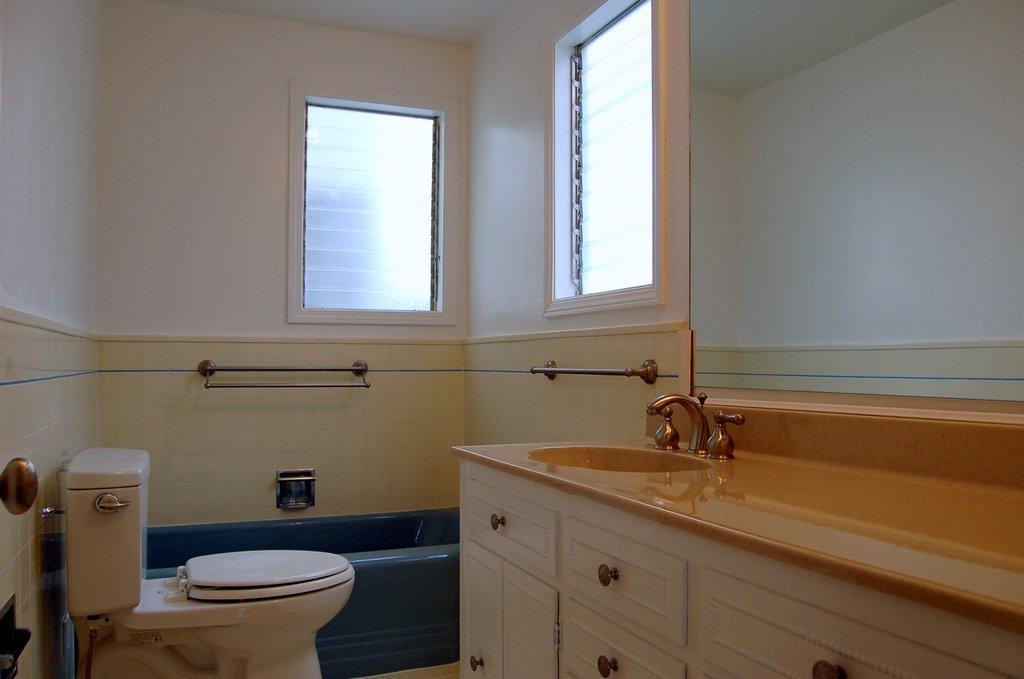Can you describe this image briefly? This picture is in the bathroom where I can see wash basin, taps, wooden drawers, commode, flush tank, stand, bathtub and glass ventilators in the background. 